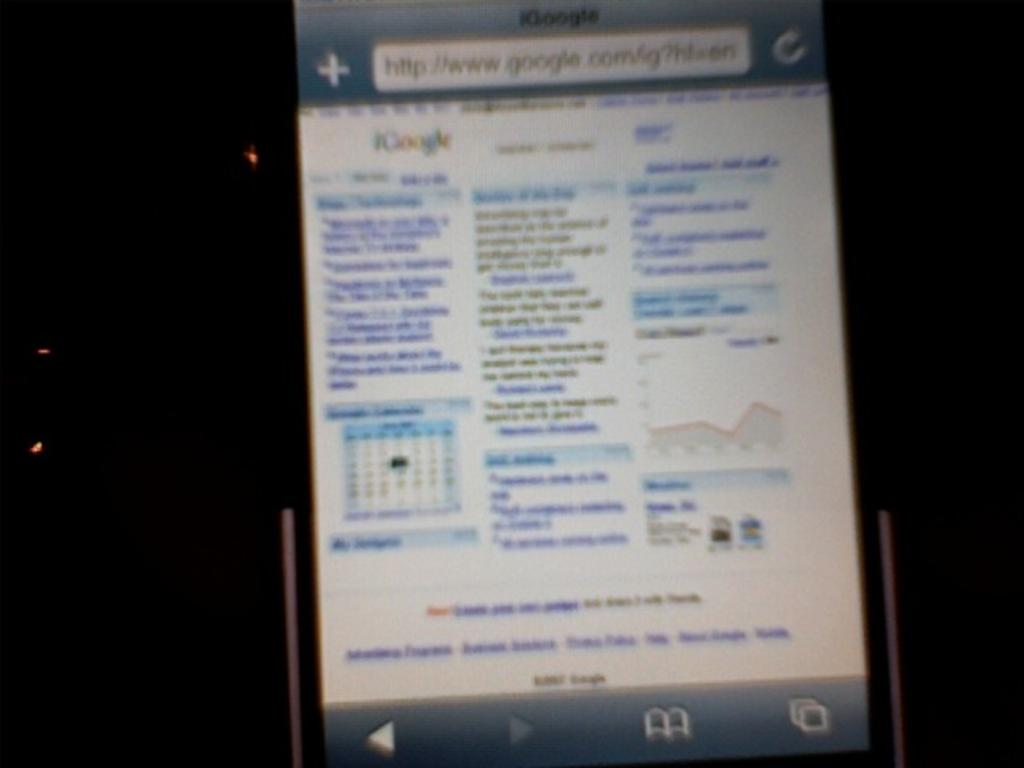<image>
Create a compact narrative representing the image presented. A blurry screen has a google address in the address bar. 